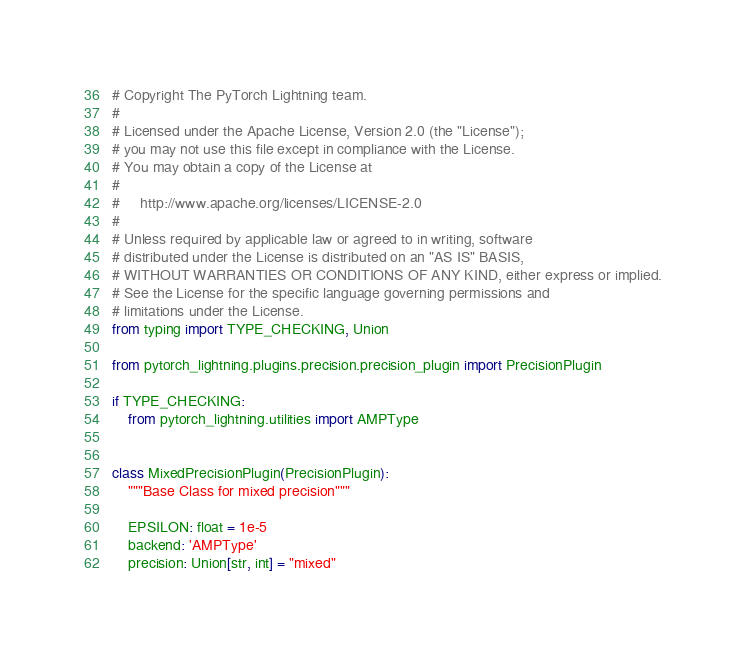Convert code to text. <code><loc_0><loc_0><loc_500><loc_500><_Python_># Copyright The PyTorch Lightning team.
#
# Licensed under the Apache License, Version 2.0 (the "License");
# you may not use this file except in compliance with the License.
# You may obtain a copy of the License at
#
#     http://www.apache.org/licenses/LICENSE-2.0
#
# Unless required by applicable law or agreed to in writing, software
# distributed under the License is distributed on an "AS IS" BASIS,
# WITHOUT WARRANTIES OR CONDITIONS OF ANY KIND, either express or implied.
# See the License for the specific language governing permissions and
# limitations under the License.
from typing import TYPE_CHECKING, Union

from pytorch_lightning.plugins.precision.precision_plugin import PrecisionPlugin

if TYPE_CHECKING:
    from pytorch_lightning.utilities import AMPType


class MixedPrecisionPlugin(PrecisionPlugin):
    """Base Class for mixed precision"""

    EPSILON: float = 1e-5
    backend: 'AMPType'
    precision: Union[str, int] = "mixed"
</code> 